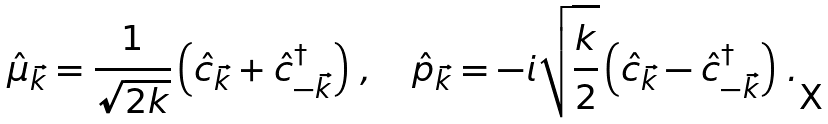<formula> <loc_0><loc_0><loc_500><loc_500>\hat { \mu } _ { \vec { k } } = \frac { 1 } { \sqrt { 2 k } } \left ( \hat { c } _ { \vec { k } } + \hat { c } _ { - \vec { k } } ^ { \dagger } \right ) \, , \quad \hat { p } _ { \vec { k } } = - i \sqrt { \frac { k } { 2 } } \left ( \hat { c } _ { \vec { k } } - \hat { c } _ { - \vec { k } } ^ { \dagger } \right ) \, .</formula> 